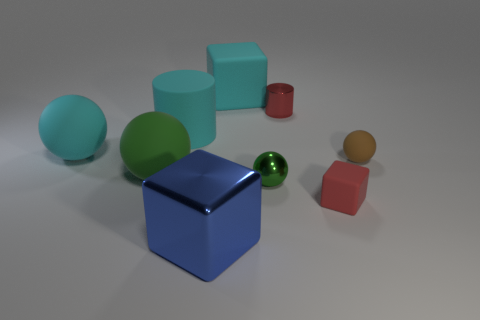Subtract all purple blocks. Subtract all cyan cylinders. How many blocks are left? 3 Add 1 small green metal spheres. How many objects exist? 10 Subtract all balls. How many objects are left? 5 Subtract 0 green cubes. How many objects are left? 9 Subtract all big purple metal spheres. Subtract all large cylinders. How many objects are left? 8 Add 1 brown rubber balls. How many brown rubber balls are left? 2 Add 4 brown balls. How many brown balls exist? 5 